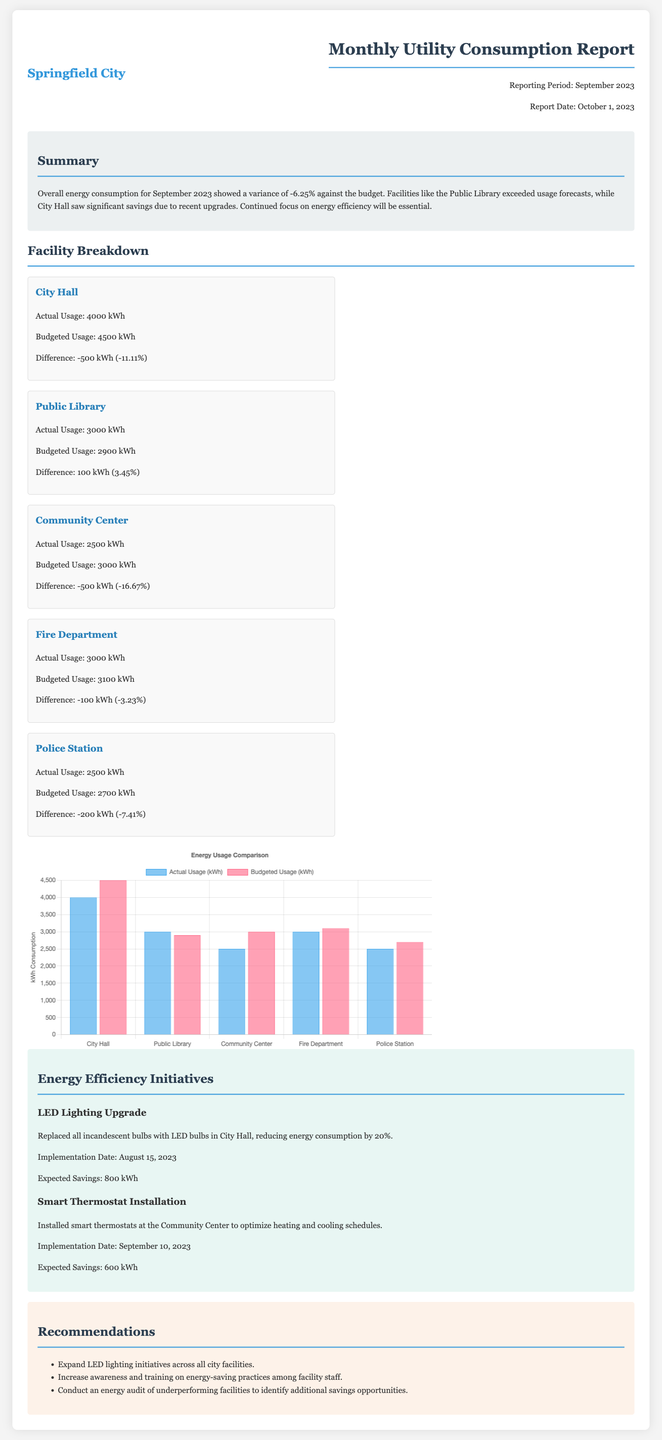what is the actual energy consumption of City Hall? The document states that City Hall's actual usage is 4000 kWh.
Answer: 4000 kWh what is the budgeted energy usage for the Public Library? According to the document, the budgeted usage for the Public Library is 2900 kWh.
Answer: 2900 kWh what was the percentage variance in overall energy consumption for September 2023? The summary mentions a variance of -6.25% in overall energy consumption.
Answer: -6.25% which facility saw significant savings due to recent upgrades? The summary indicates that City Hall saw significant savings due to upgrades.
Answer: City Hall what energy efficiency initiative was implemented at the Community Center? The document states that smart thermostats were installed at the Community Center.
Answer: Smart Thermostat Installation how much energy savings is expected from the LED lighting upgrade at City Hall? The expected savings from the LED lighting upgrade at City Hall is 800 kWh.
Answer: 800 kWh what is the difference in energy usage for the Fire Department? The document shows that the difference for the Fire Department is -100 kWh.
Answer: -100 kWh what is one of the recommendations mentioned in the report? The recommendations include expanding LED lighting initiatives across all city facilities.
Answer: Expand LED lighting initiatives across all city facilities what type of chart is used in the report to display energy usage? The document describes the chart as a bar chart for energy usage comparison.
Answer: Bar chart 